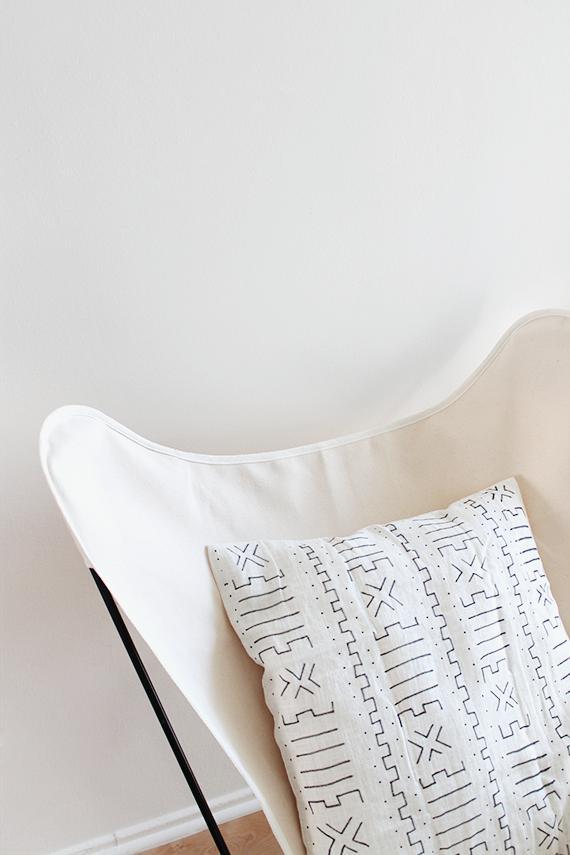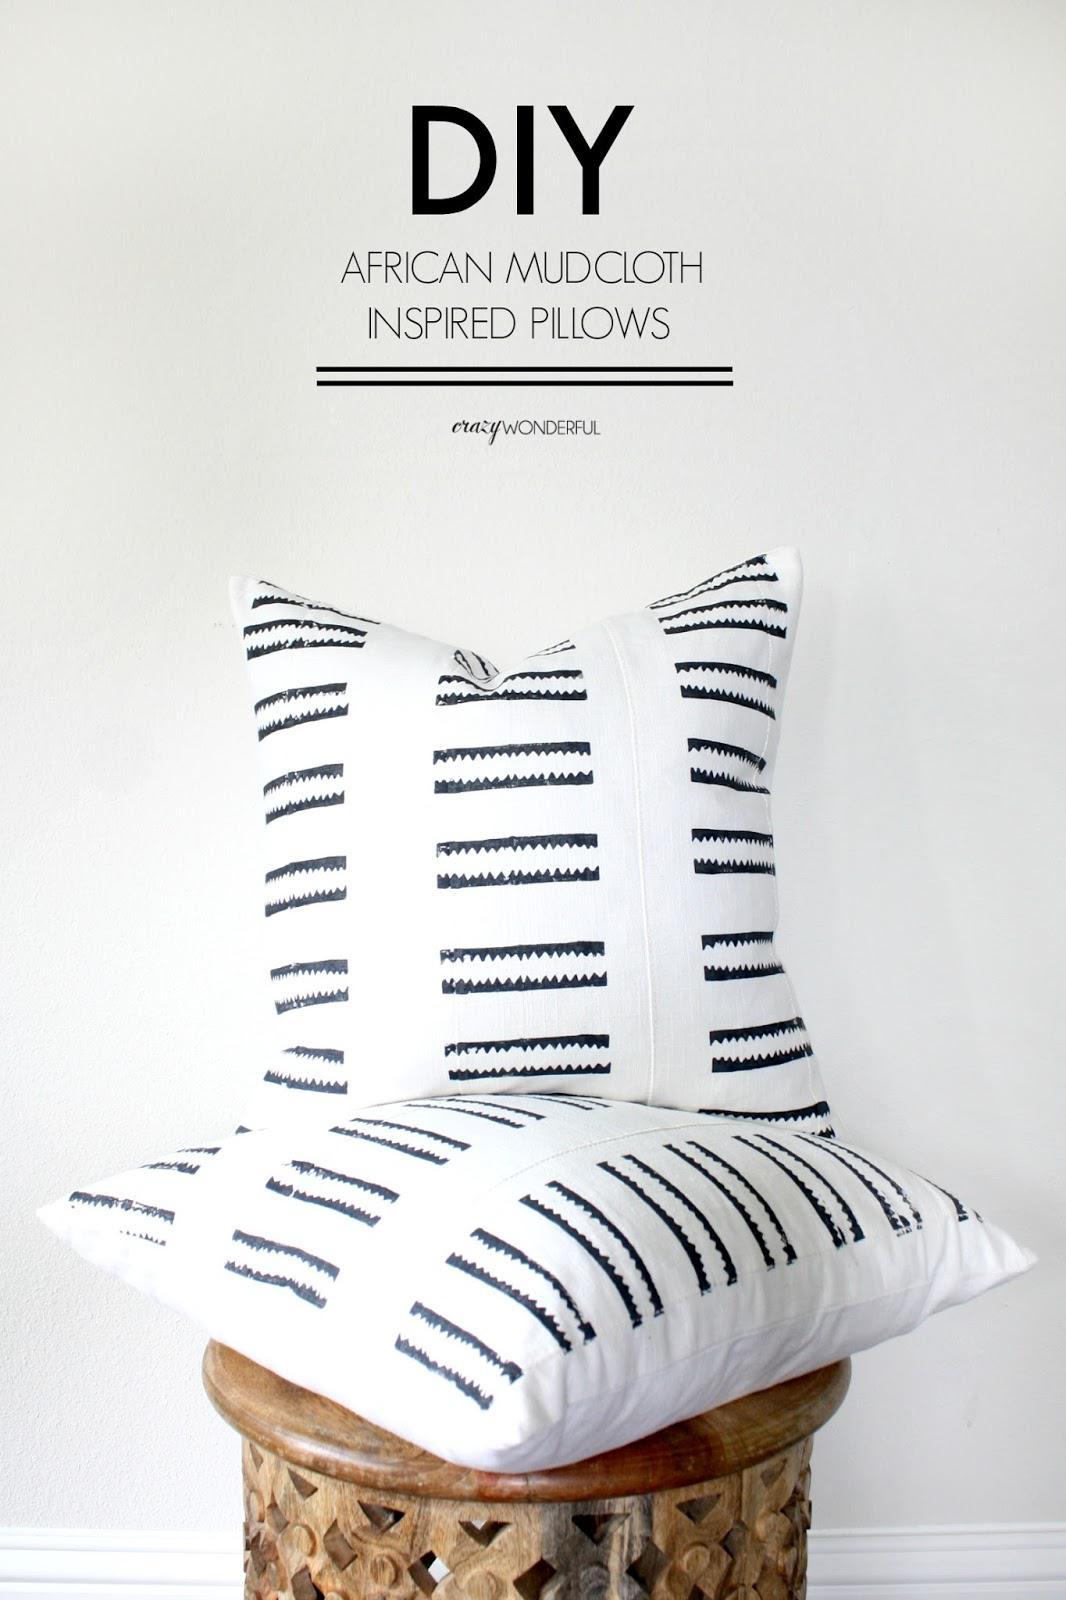The first image is the image on the left, the second image is the image on the right. Considering the images on both sides, is "there is a bench in front of a window with a fringed blanket draped on it" valid? Answer yes or no. No. 